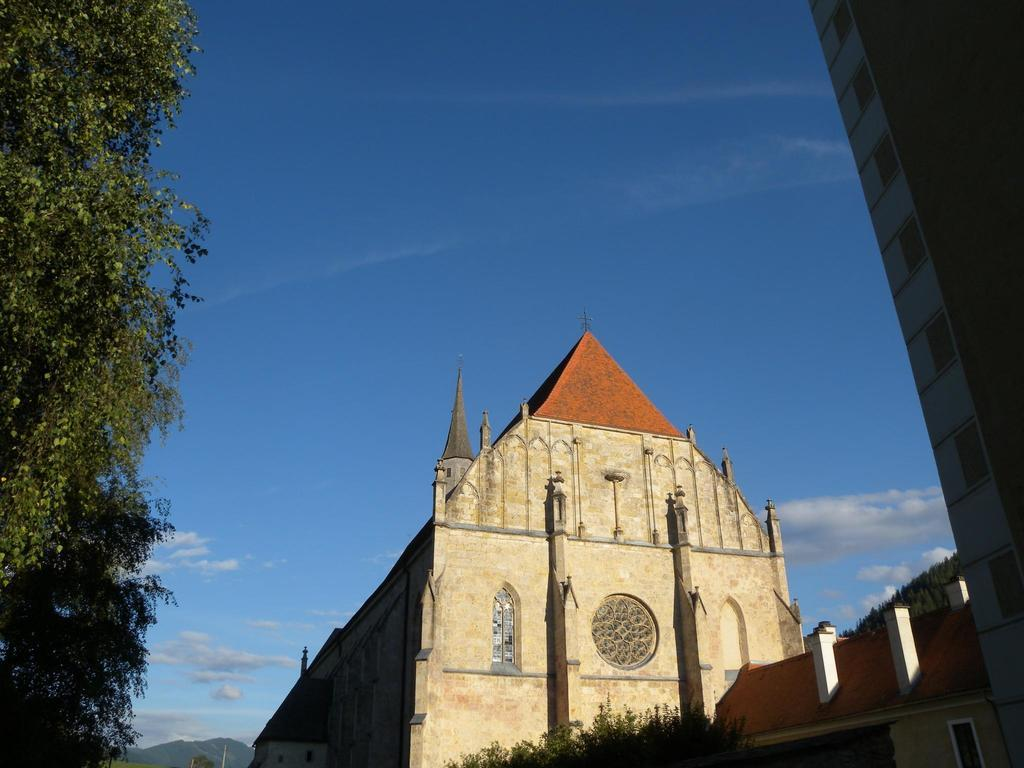What type of structures can be seen in the image? There are buildings in the image. What other natural elements are present in the image? There are trees in the image. What is visible at the top of the image? The sky is clear and visible at the top of the image. What color of paint is being used on the cub in the image? There is no cub present in the image, so it is not possible to determine the color of paint being used. 